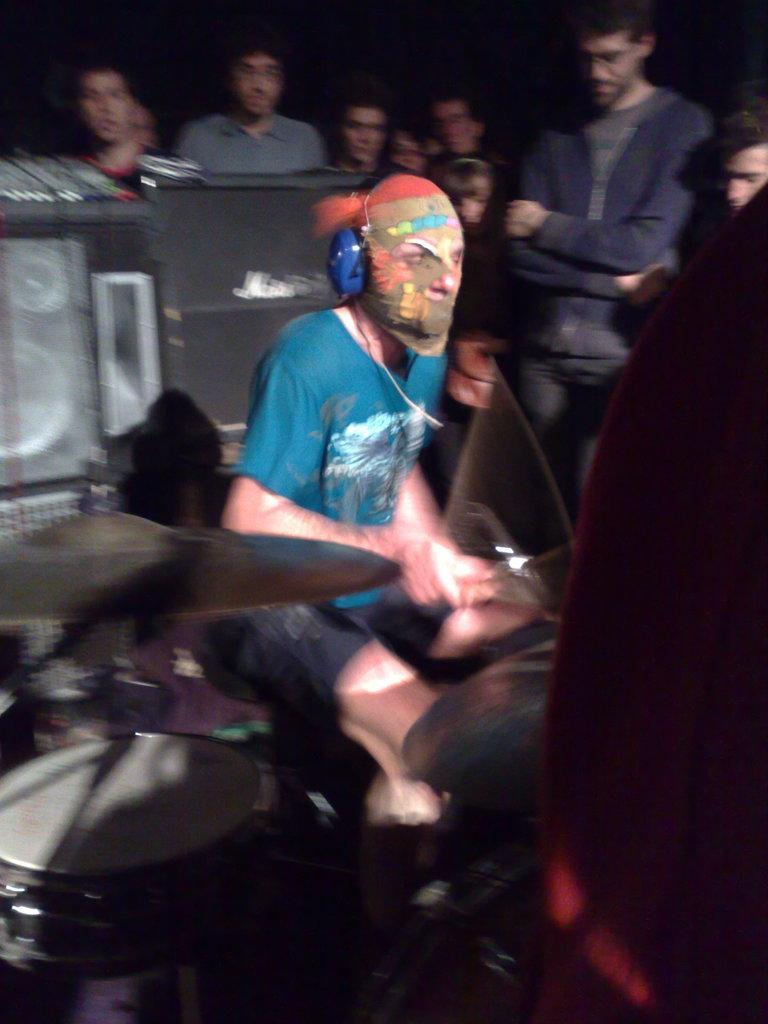Describe this image in one or two sentences. In this image, we can see people and one of them is wearing a headset and a mask on his face and holding an object. In the background, there are some more people and we can see musical instruments. 